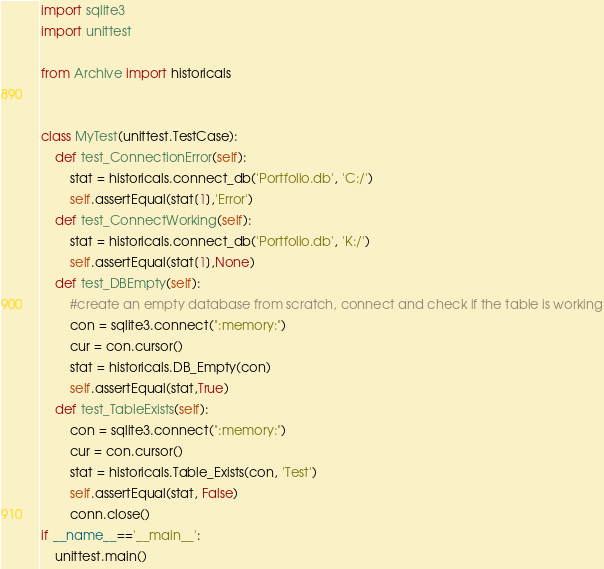Convert code to text. <code><loc_0><loc_0><loc_500><loc_500><_Python_>import sqlite3
import unittest

from Archive import historicals


class MyTest(unittest.TestCase):
    def test_ConnectionError(self):
        stat = historicals.connect_db('Portfolio.db', 'C:/')
        self.assertEqual(stat[1],'Error')
    def test_ConnectWorking(self):
        stat = historicals.connect_db('Portfolio.db', 'K:/')
        self.assertEqual(stat[1],None)
    def test_DBEmpty(self):
        #create an empty database from scratch, connect and check if the table is working
        con = sqlite3.connect(":memory:")
        cur = con.cursor()
        stat = historicals.DB_Empty(con)
        self.assertEqual(stat,True)
    def test_TableExists(self):
        con = sqlite3.connect(":memory:")
        cur = con.cursor()
        stat = historicals.Table_Exists(con, 'Test')
        self.assertEqual(stat, False)
        conn.close()
if __name__=='__main__':
    unittest.main()</code> 